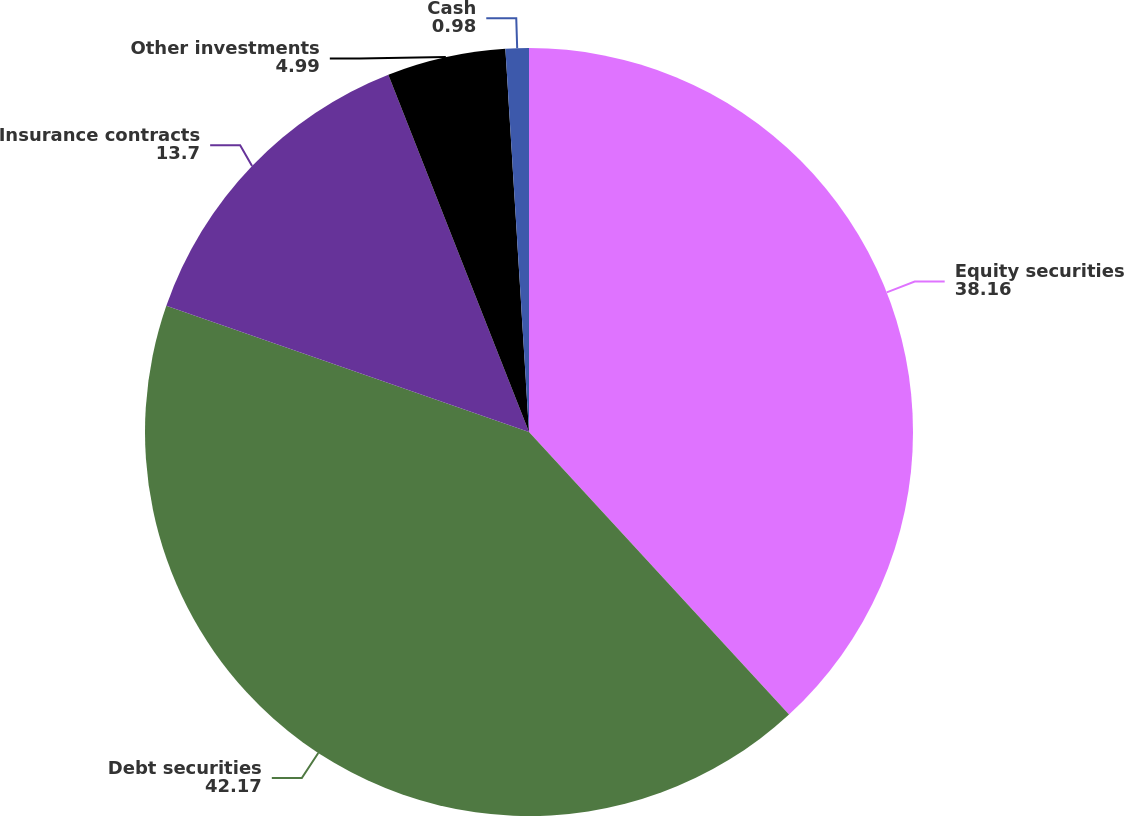Convert chart to OTSL. <chart><loc_0><loc_0><loc_500><loc_500><pie_chart><fcel>Equity securities<fcel>Debt securities<fcel>Insurance contracts<fcel>Other investments<fcel>Cash<nl><fcel>38.16%<fcel>42.17%<fcel>13.7%<fcel>4.99%<fcel>0.98%<nl></chart> 